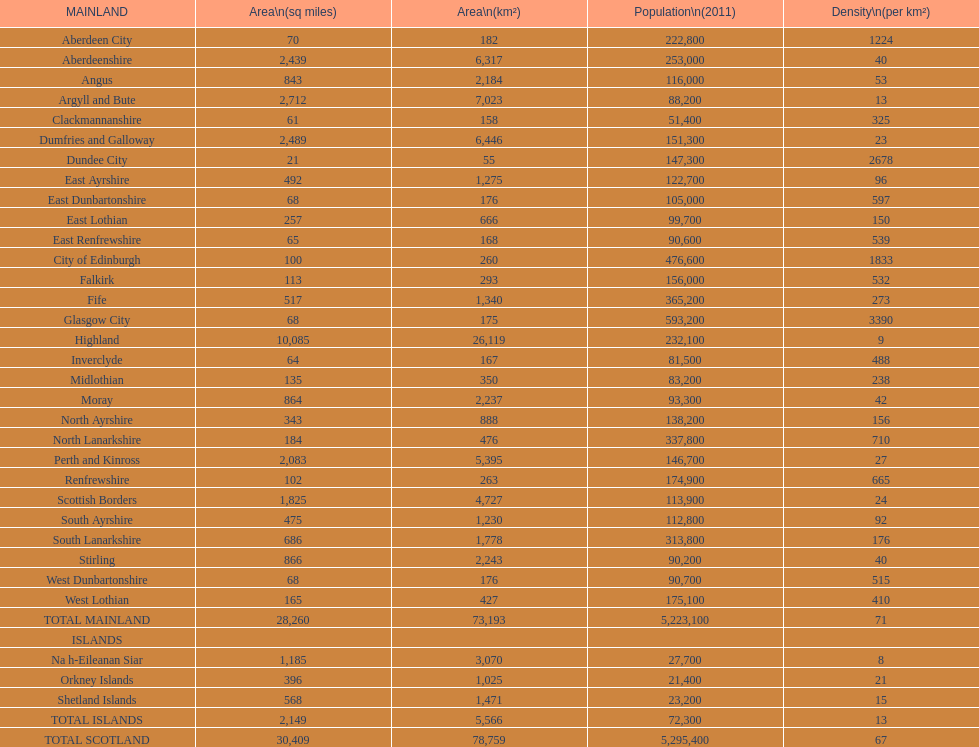If you were to sort the locations from the tiniest to biggest area, which one would be at the beginning of the list? Dundee City. 